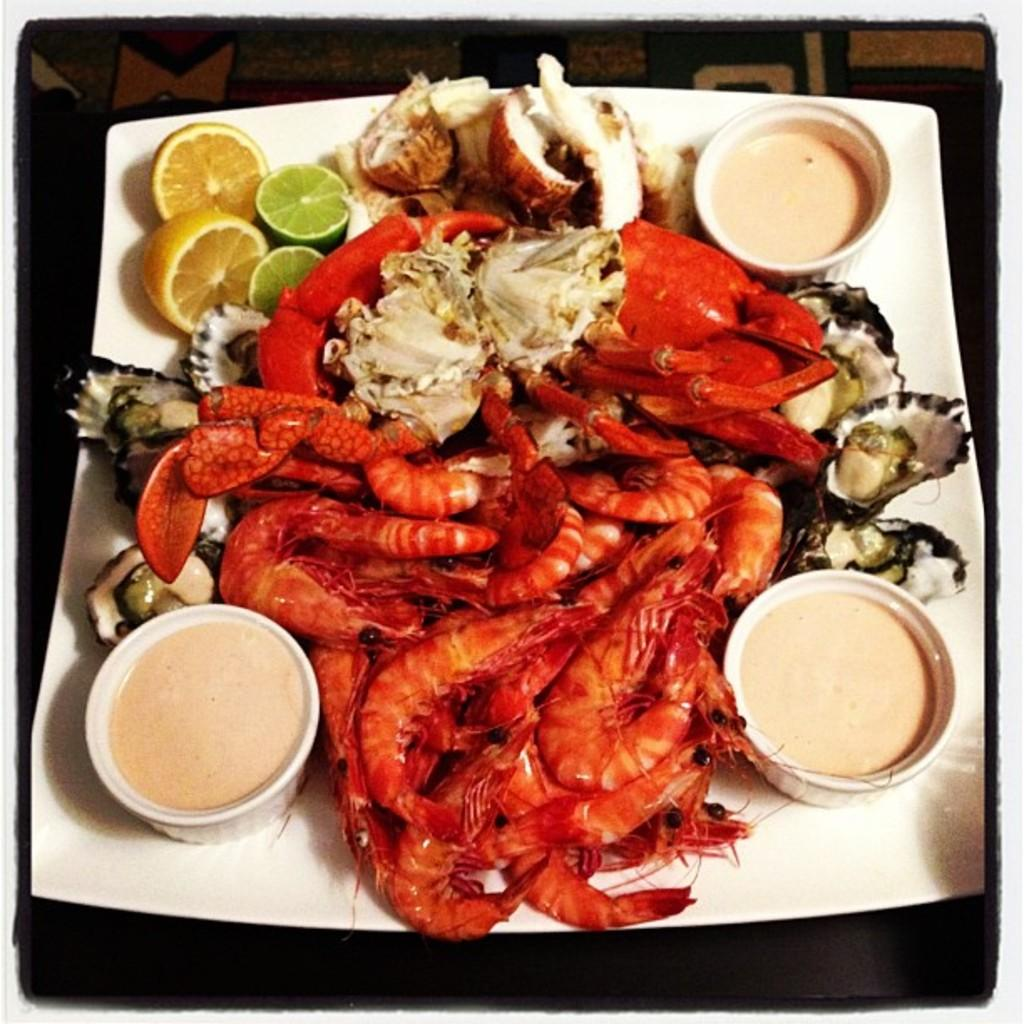What is present on the plate in the image? There are food items served in a plate. Can you describe the background of the image? The background of the image is visible, but no specific details are provided. How many horses can be seen flexing their muscles in the image? There are no horses or muscles present in the image; it features a plate of food items and a visible background. 